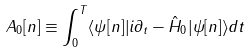<formula> <loc_0><loc_0><loc_500><loc_500>A _ { 0 } [ n ] \equiv \int _ { 0 } ^ { T } \langle \psi [ n ] | i \partial _ { t } - \hat { H } _ { 0 } | \psi [ n ] \rangle d t</formula> 